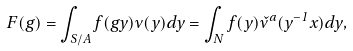<formula> <loc_0><loc_0><loc_500><loc_500>F ( g ) = \int _ { S \slash A } f ( g y ) \nu ( y ) d y = \int _ { N } f ( y ) \check { \nu } ^ { a } ( y ^ { - 1 } x ) d y ,</formula> 